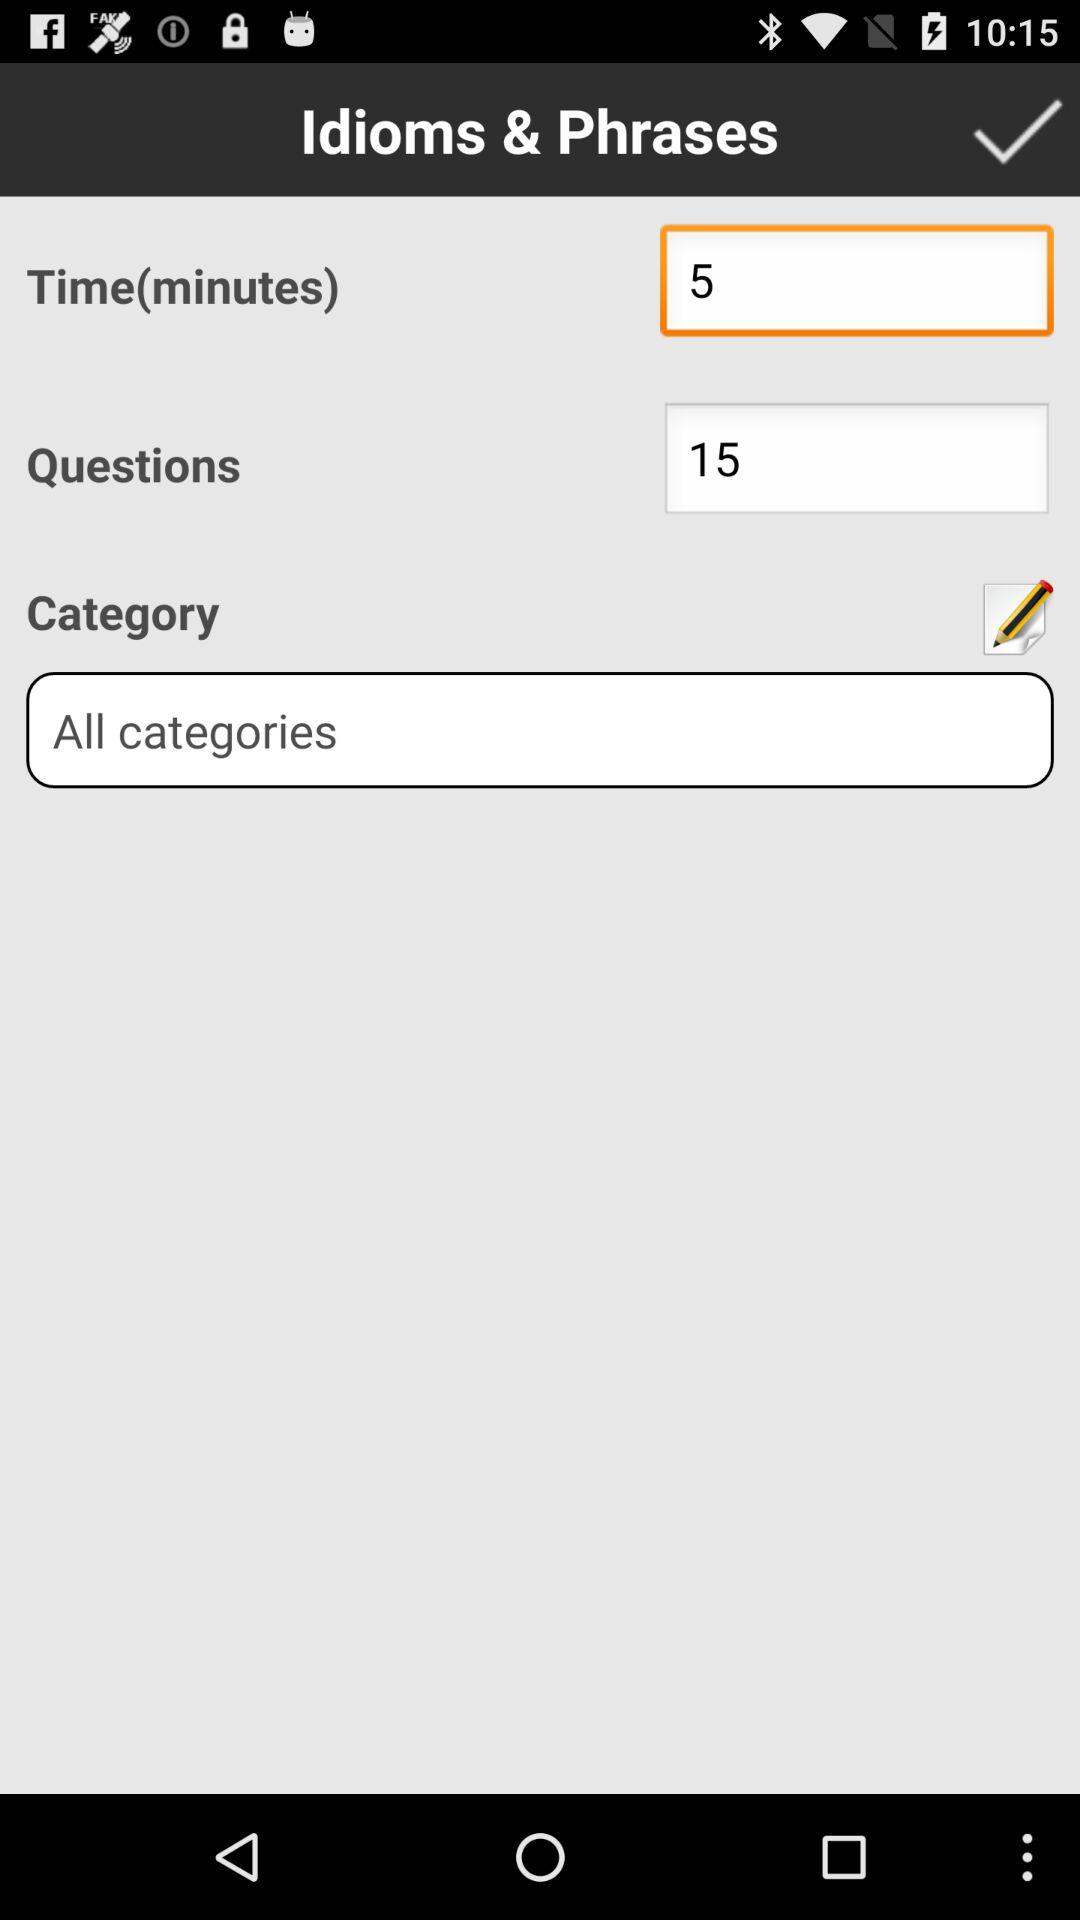What is the time limit? The time limit is 5 minutes. 